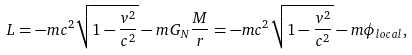<formula> <loc_0><loc_0><loc_500><loc_500>L = - m c ^ { 2 } \sqrt { 1 - \frac { v ^ { 2 } } { c ^ { 2 } } } - m G _ { N } \frac { M } { r } = - m c ^ { 2 } \sqrt { 1 - \frac { v ^ { 2 } } { c ^ { 2 } } } - m \phi _ { l o c a l } ,</formula> 